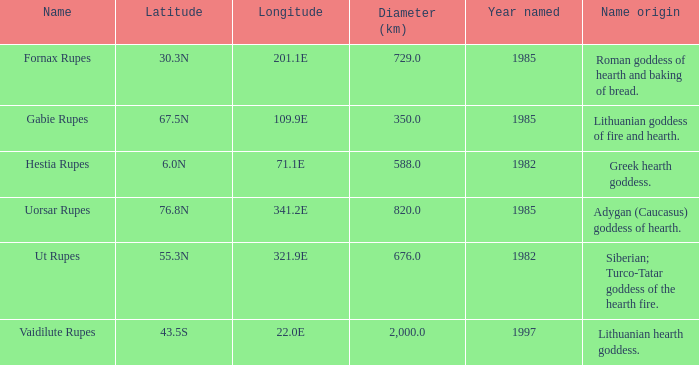5n, what is the distance across? 350.0. 